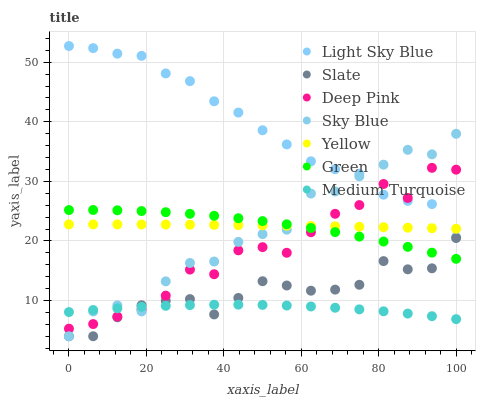Does Medium Turquoise have the minimum area under the curve?
Answer yes or no. Yes. Does Light Sky Blue have the maximum area under the curve?
Answer yes or no. Yes. Does Slate have the minimum area under the curve?
Answer yes or no. No. Does Slate have the maximum area under the curve?
Answer yes or no. No. Is Yellow the smoothest?
Answer yes or no. Yes. Is Deep Pink the roughest?
Answer yes or no. Yes. Is Slate the smoothest?
Answer yes or no. No. Is Slate the roughest?
Answer yes or no. No. Does Slate have the lowest value?
Answer yes or no. Yes. Does Yellow have the lowest value?
Answer yes or no. No. Does Light Sky Blue have the highest value?
Answer yes or no. Yes. Does Slate have the highest value?
Answer yes or no. No. Is Medium Turquoise less than Yellow?
Answer yes or no. Yes. Is Light Sky Blue greater than Green?
Answer yes or no. Yes. Does Yellow intersect Green?
Answer yes or no. Yes. Is Yellow less than Green?
Answer yes or no. No. Is Yellow greater than Green?
Answer yes or no. No. Does Medium Turquoise intersect Yellow?
Answer yes or no. No. 